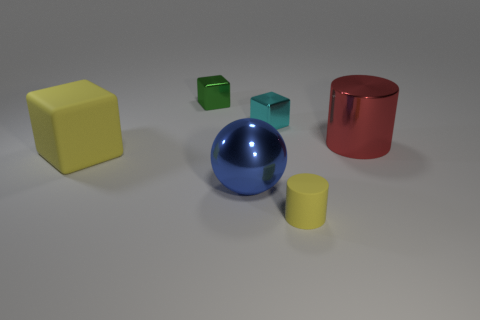There is a tiny shiny thing that is to the right of the tiny green thing; does it have the same shape as the metal object right of the rubber cylinder?
Your response must be concise. No. The big object that is to the left of the small yellow matte cylinder and right of the large matte block has what shape?
Provide a short and direct response. Sphere. The cylinder that is made of the same material as the tiny green object is what size?
Offer a terse response. Large. Are there fewer tiny gray things than big blue objects?
Your answer should be very brief. Yes. There is a big ball that is to the left of the tiny thing in front of the cylinder behind the big yellow matte thing; what is its material?
Keep it short and to the point. Metal. Does the yellow object that is in front of the large blue sphere have the same material as the cylinder that is behind the big matte cube?
Provide a succinct answer. No. What is the size of the object that is both to the right of the tiny cyan cube and in front of the big yellow cube?
Offer a terse response. Small. There is a cube that is the same size as the blue thing; what is its material?
Offer a very short reply. Rubber. How many tiny green objects are left of the yellow matte thing that is behind the big metal object on the left side of the small yellow cylinder?
Provide a succinct answer. 0. Do the metallic thing that is in front of the big red shiny thing and the tiny shiny object in front of the green shiny cube have the same color?
Provide a short and direct response. No. 